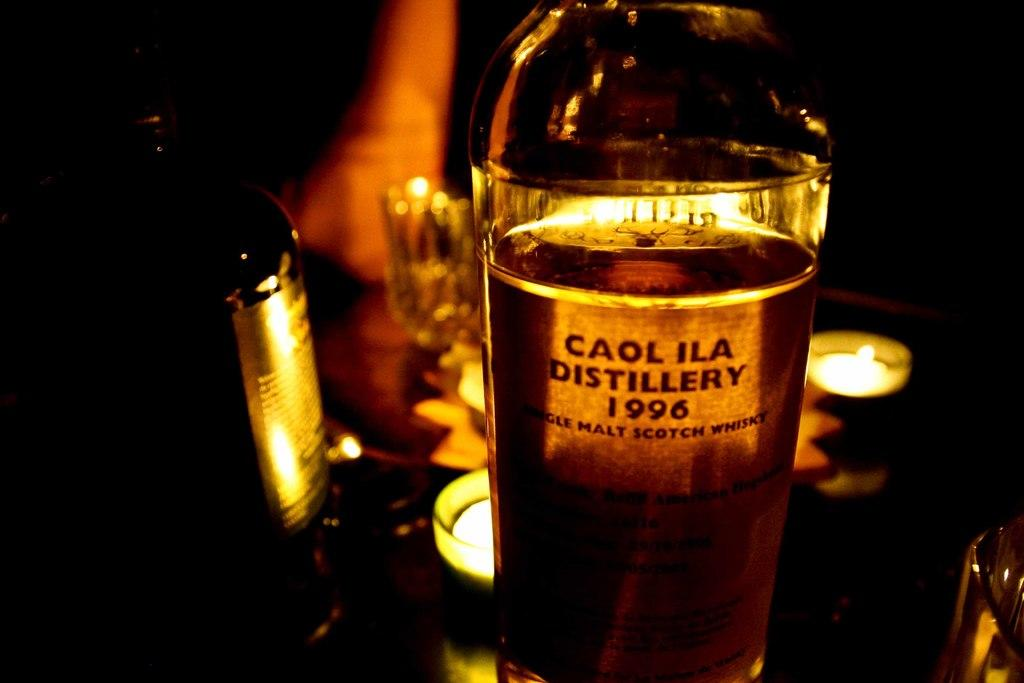Provide a one-sentence caption for the provided image. Bottle of beer called Caol Ila placed on top of a table. 